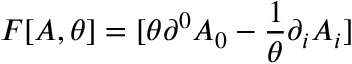<formula> <loc_0><loc_0><loc_500><loc_500>F [ A , \theta ] = [ \theta \partial ^ { 0 } A _ { 0 } - \frac { 1 } { \theta } \partial _ { i } A _ { i } ]</formula> 